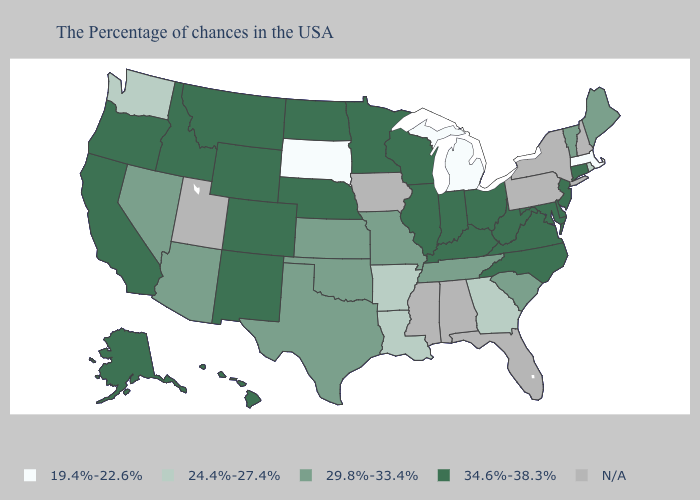How many symbols are there in the legend?
Short answer required. 5. Does Kansas have the highest value in the USA?
Answer briefly. No. What is the value of Hawaii?
Short answer required. 34.6%-38.3%. What is the value of Rhode Island?
Answer briefly. 24.4%-27.4%. Name the states that have a value in the range 19.4%-22.6%?
Write a very short answer. Massachusetts, Michigan, South Dakota. Is the legend a continuous bar?
Write a very short answer. No. Does the map have missing data?
Answer briefly. Yes. Among the states that border North Dakota , which have the lowest value?
Be succinct. South Dakota. What is the lowest value in states that border New Mexico?
Answer briefly. 29.8%-33.4%. What is the value of Montana?
Quick response, please. 34.6%-38.3%. Among the states that border Oklahoma , which have the lowest value?
Concise answer only. Arkansas. Which states have the lowest value in the USA?
Be succinct. Massachusetts, Michigan, South Dakota. Which states have the highest value in the USA?
Quick response, please. Connecticut, New Jersey, Delaware, Maryland, Virginia, North Carolina, West Virginia, Ohio, Kentucky, Indiana, Wisconsin, Illinois, Minnesota, Nebraska, North Dakota, Wyoming, Colorado, New Mexico, Montana, Idaho, California, Oregon, Alaska, Hawaii. Does the first symbol in the legend represent the smallest category?
Concise answer only. Yes. 